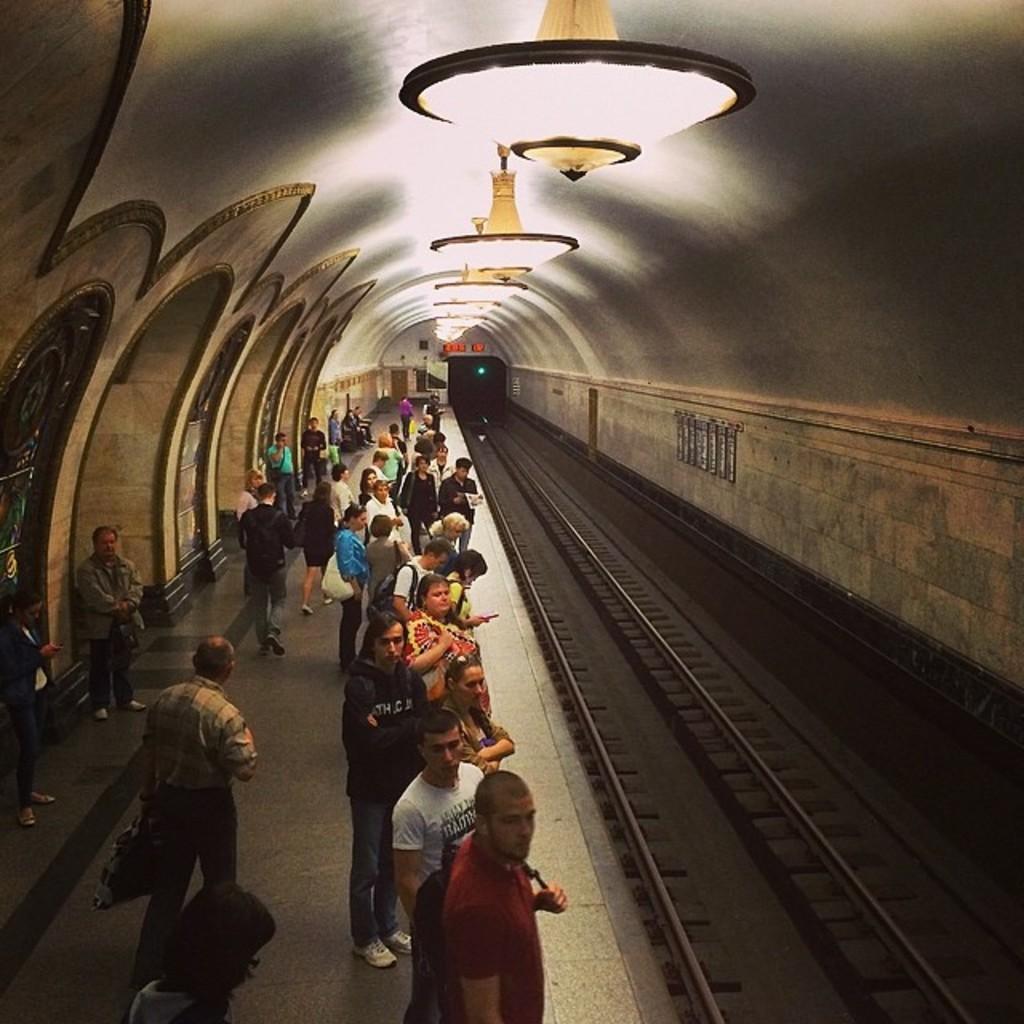Can you describe this image briefly? In this picture I can see group of people are standing on a railway platform. On the right side I can see railway tracks, tunnel and lights. 